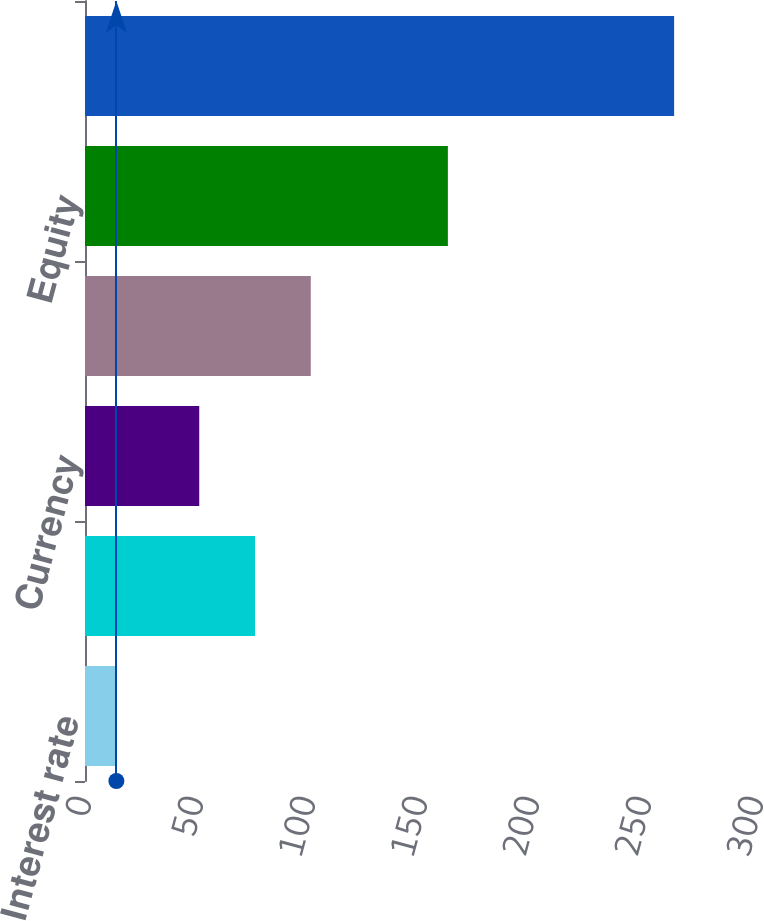<chart> <loc_0><loc_0><loc_500><loc_500><bar_chart><fcel>Interest rate<fcel>Currency(1)<fcel>Currency<fcel>Credit<fcel>Equity<fcel>Total Derivative Impact<nl><fcel>14<fcel>75.9<fcel>51<fcel>100.8<fcel>162<fcel>263<nl></chart> 